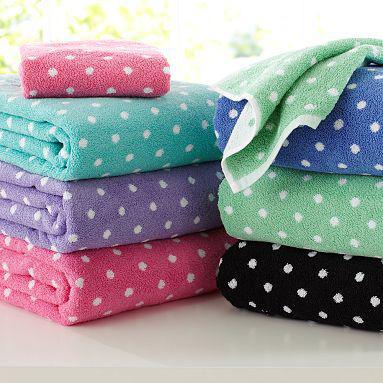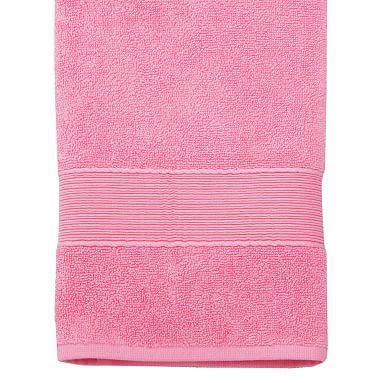The first image is the image on the left, the second image is the image on the right. For the images shown, is this caption "All images contain towels with a spotted pattern." true? Answer yes or no. No. The first image is the image on the left, the second image is the image on the right. For the images shown, is this caption "A black towel is folded under a green folded towel." true? Answer yes or no. Yes. 